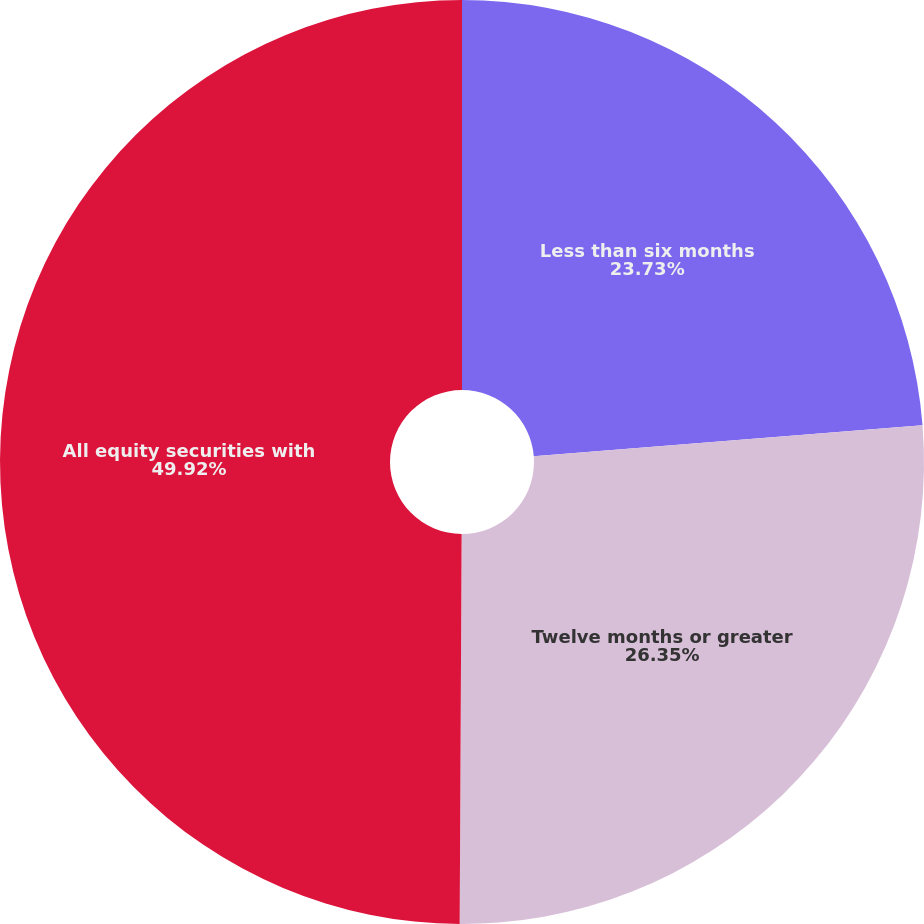<chart> <loc_0><loc_0><loc_500><loc_500><pie_chart><fcel>Less than six months<fcel>Twelve months or greater<fcel>All equity securities with<nl><fcel>23.73%<fcel>26.35%<fcel>49.92%<nl></chart> 